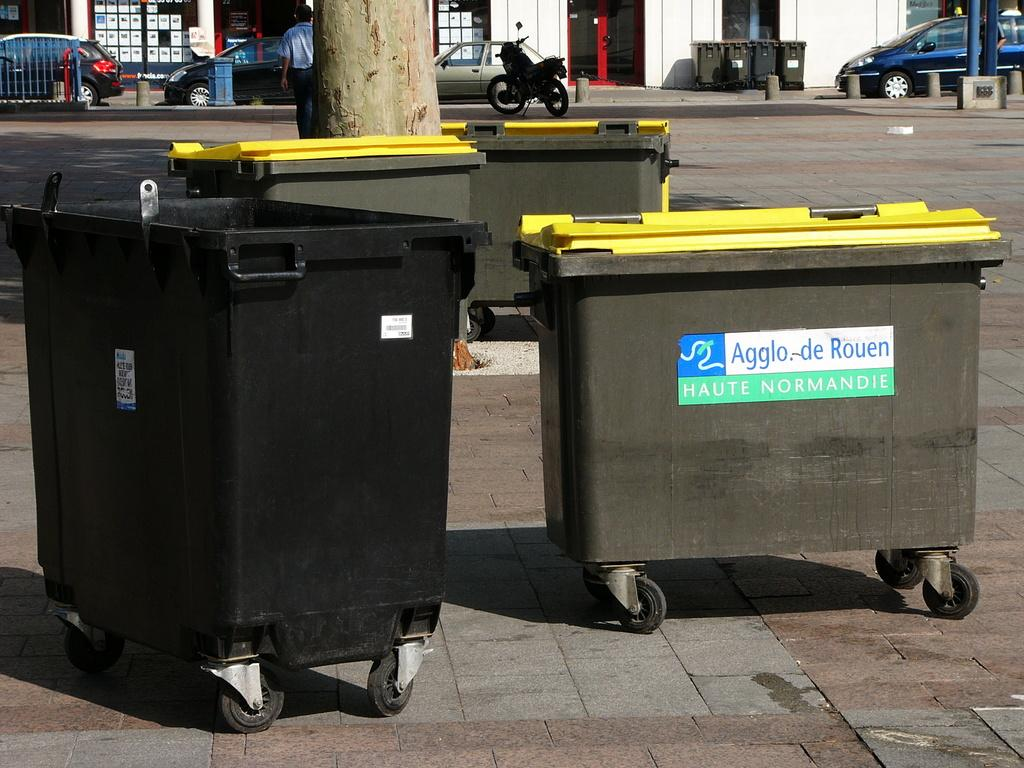Provide a one-sentence caption for the provided image. Large bins on wheels that say Agglo De Rouen. 